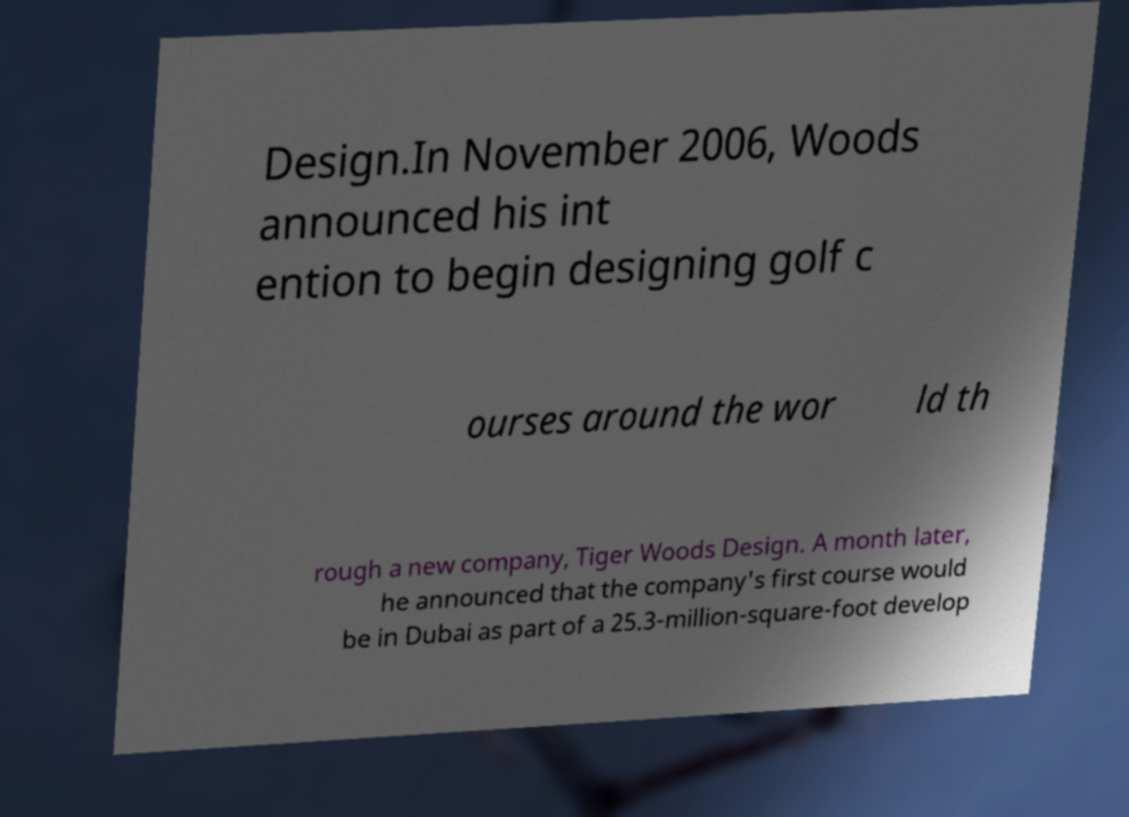Could you extract and type out the text from this image? Design.In November 2006, Woods announced his int ention to begin designing golf c ourses around the wor ld th rough a new company, Tiger Woods Design. A month later, he announced that the company's first course would be in Dubai as part of a 25.3-million-square-foot develop 